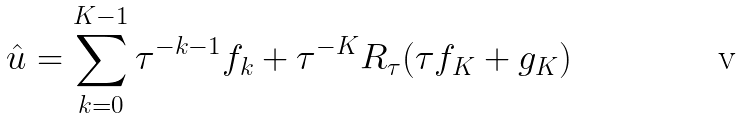<formula> <loc_0><loc_0><loc_500><loc_500>\hat { u } = \sum _ { k = 0 } ^ { K - 1 } \tau ^ { - k - 1 } f _ { k } + \tau ^ { - K } R _ { \tau } ( \tau f _ { K } + g _ { K } )</formula> 